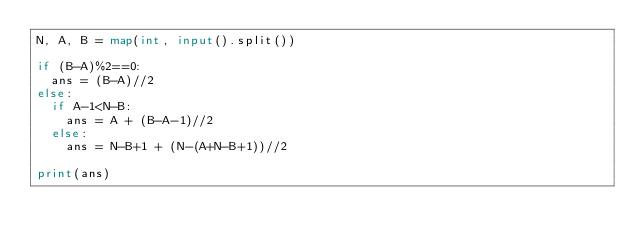Convert code to text. <code><loc_0><loc_0><loc_500><loc_500><_Python_>N, A, B = map(int, input().split())

if (B-A)%2==0:
  ans = (B-A)//2
else:
  if A-1<N-B:
    ans = A + (B-A-1)//2
  else:
    ans = N-B+1 + (N-(A+N-B+1))//2
    
print(ans)</code> 